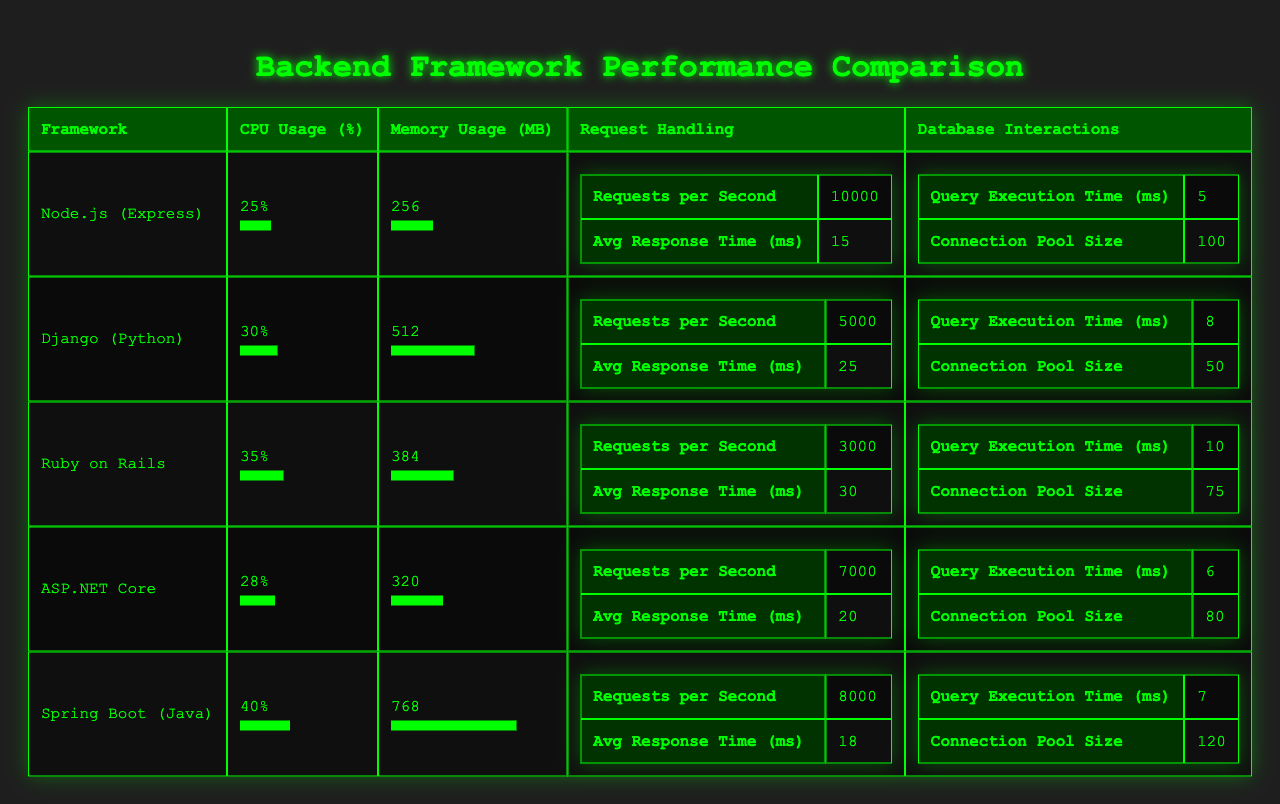What's the CPU usage of Node.js (Express)? The table shows that Node.js (Express) has a CPU usage of 25%.
Answer: 25% What is the memory usage of Ruby on Rails? According to the data, Ruby on Rails uses 384 MB of memory.
Answer: 384 MB Which framework has the lowest requests per second? The table indicates that Ruby on Rails handles the lowest requests per second at 3000.
Answer: 3000 What is the average response time for ASP.NET Core? For ASP.NET Core, the average response time is stated as 20 ms in the table.
Answer: 20 ms Which framework has the highest memory usage? The data reveals that Spring Boot (Java) has the highest memory usage at 768 MB.
Answer: 768 MB What is the total CPU usage for Node.js (Express) and Django (Python)? The CPU usage for Node.js (Express) is 25% and for Django (Python) it is 30%. Adding these gives 25 + 30 = 55%.
Answer: 55% Is the query execution time for ASP.NET Core less than that of Ruby on Rails? The query execution time for ASP.NET Core is 6 ms, while for Ruby on Rails it is 10 ms. Since 6 is less than 10, the statement is true.
Answer: Yes What is the connection pool size difference between Spring Boot (Java) and Django (Python)? Spring Boot (Java) has a connection pool size of 120 and Django (Python) has 50. The difference is 120 - 50 = 70.
Answer: 70 Which framework has a higher average response time, Django or Ruby on Rails? The average response time for Django is 25 ms, while for Ruby on Rails, it is 30 ms. Therefore, Ruby on Rails has a higher average response time.
Answer: Ruby on Rails What percentage of CPU usage is shared between Node.js (Express) and ASP.NET Core? Node.js (Express) uses 25% CPU and ASP.NET Core uses 28%. The total shared percentage is 25 + 28 = 53%.
Answer: 53% Does the database interaction time for Spring Boot (Java) exceed that of Node.js (Express)? The query execution time for Spring Boot (Java) is 7 ms while Node.js (Express) is 5 ms. Since 7 is greater than 5, the statement is true.
Answer: Yes Which backend framework is able to handle more requests per second than Ruby on Rails? The frameworks that handle more requests than Ruby on Rails (3000 r/s) are Node.js (Express) (10000), Django (Python) (5000), and ASP.NET Core (7000).
Answer: Three frameworks If we calculate the average memory usage of all frameworks, what would that be? The total memory usage is 256 + 512 + 384 + 320 + 768 = 2240 MB. There are 5 frameworks, so the average is 2240 / 5 = 448 MB.
Answer: 448 MB 